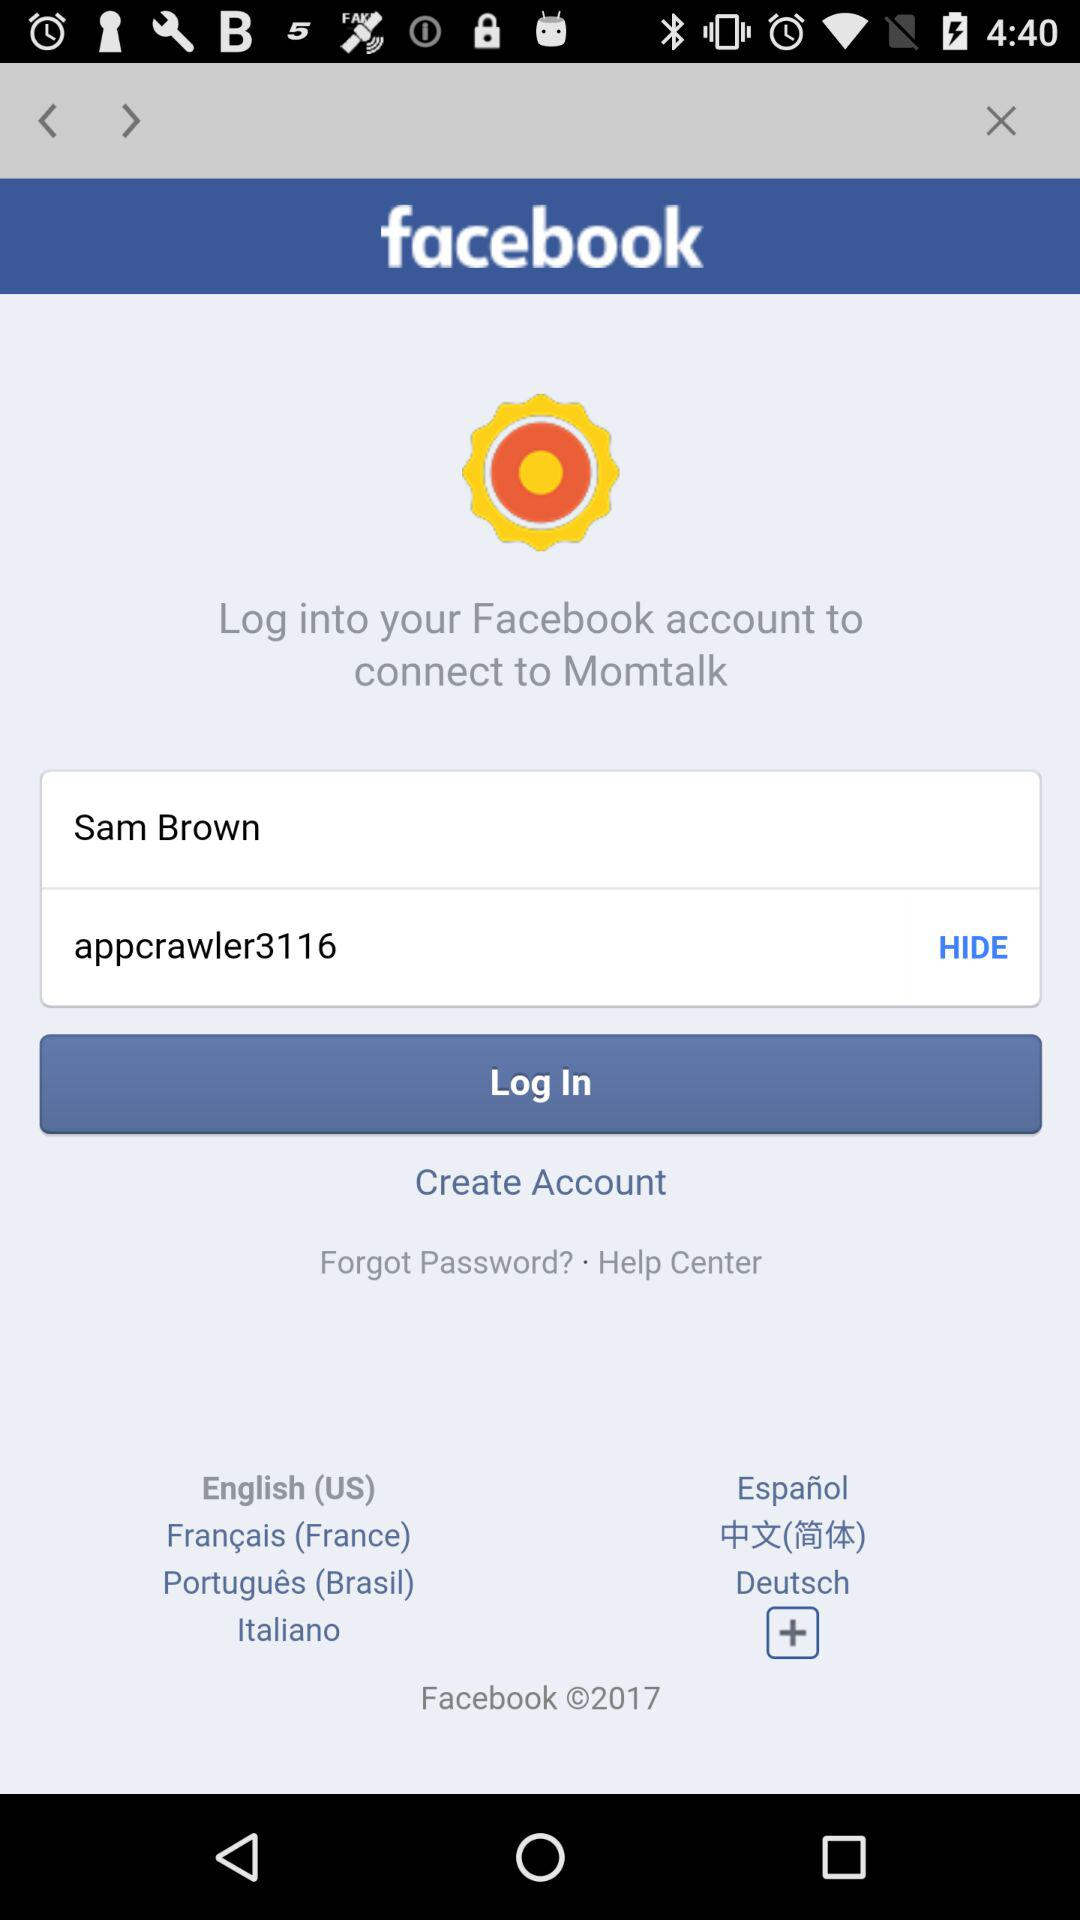What is the user name? The user name is Sam Brown. 